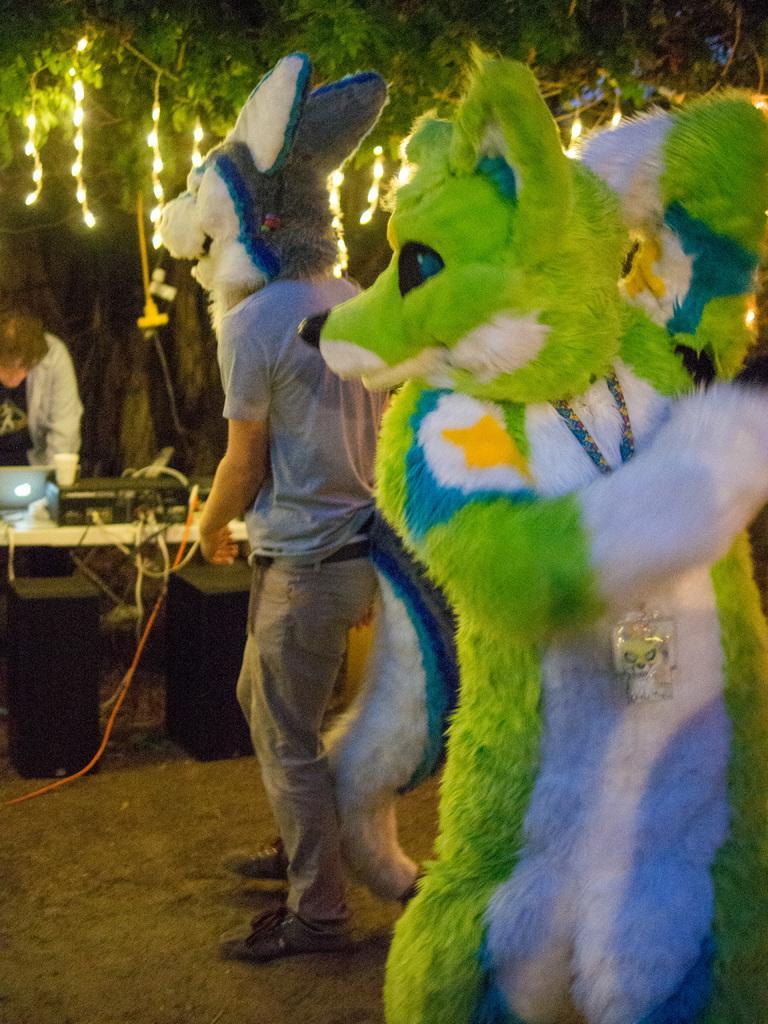Can you describe this image briefly? In this image there are two people dressed in animal masks, in front of them on the table there are a few electrical equipment and a laptop and a glass and speakers and there are fewer cables, in front of the table there is a person, at the top of the image there are decorative lights on a tree. 